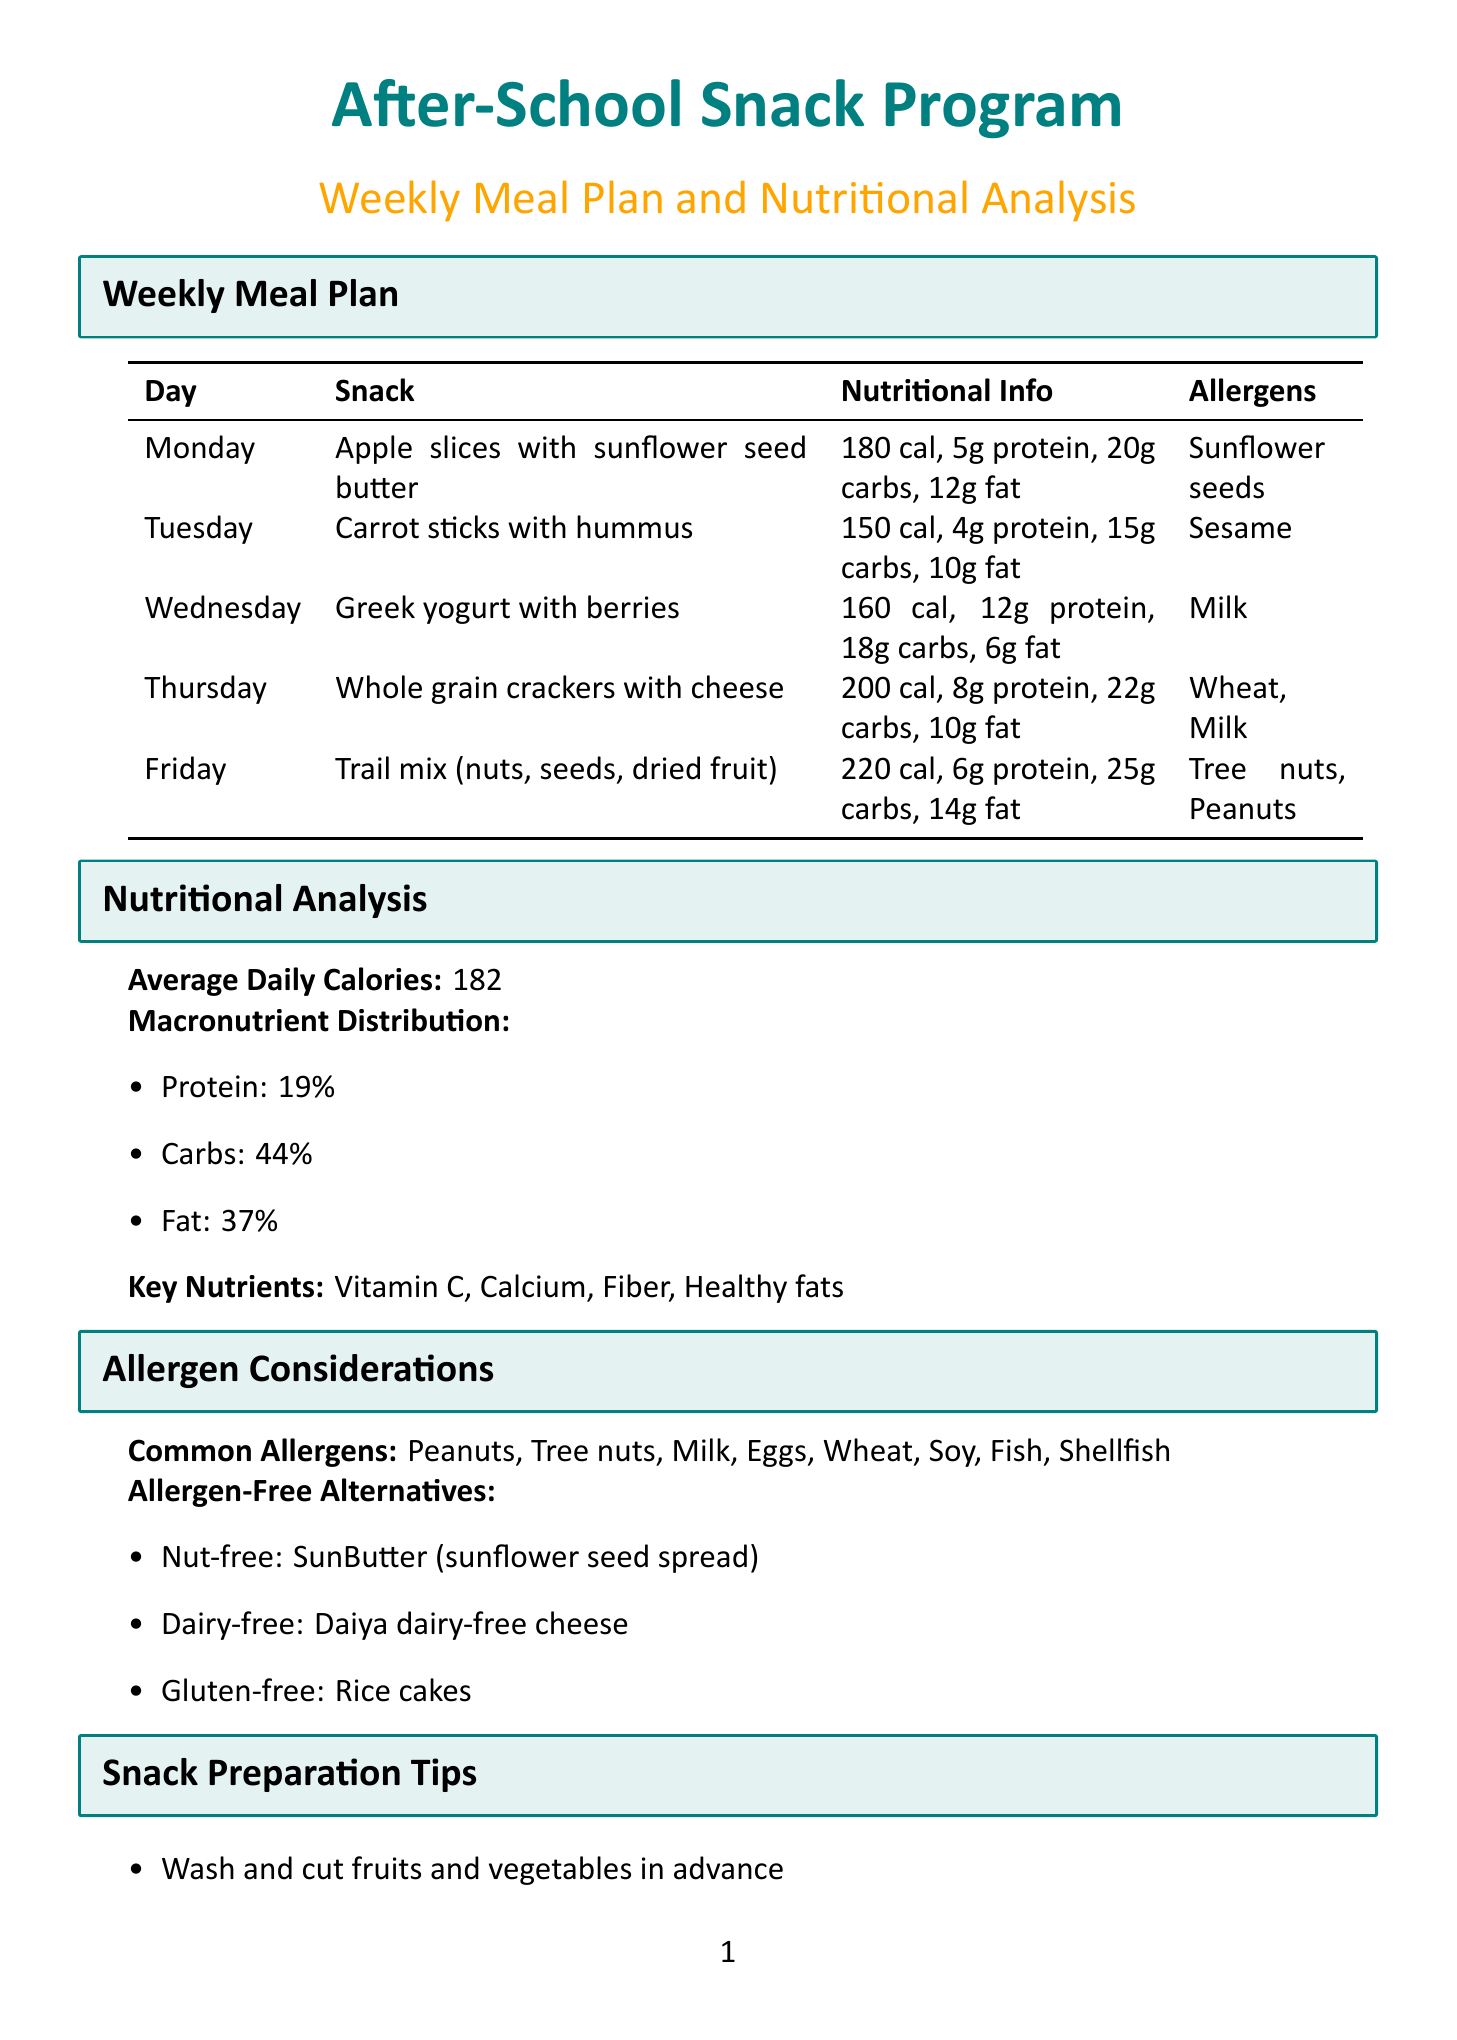What is the snack for Wednesday? The snack listed for Wednesday is Greek yogurt with berries.
Answer: Greek yogurt with berries How many calories are in the snack on Tuesday? The amount of calories for the snack on Tuesday, which is carrot sticks with hummus, is mentioned as 150 calories.
Answer: 150 What percentage of the macronutrient distribution is fat? The document states that fat accounts for 37% of the macronutrient distribution.
Answer: 37% Which day features a snack containing tree nuts? The snack containing tree nuts is scheduled for Friday, which is trail mix.
Answer: Friday What allergen is associated with the Greek yogurt snack? The allergen associated with the Greek yogurt snack is milk, as stated in the document.
Answer: Milk What is the name of the local allergen-free bakery? The document provides the name of the allergen-free bakery as Safe Bites Bakery.
Answer: Safe Bites Bakery What is the average daily calorie intake according to the nutritional analysis? The average daily calories are explicitly stated as 182.
Answer: 182 What type of lesson is included in the educational components? MyPlate food groups are listed as one of the nutrition lessons included.
Answer: MyPlate food groups What allergen-free alternative is suggested for nut-free options? The allergen-free alternative suggested for nut-free options is SunButter.
Answer: SunButter 